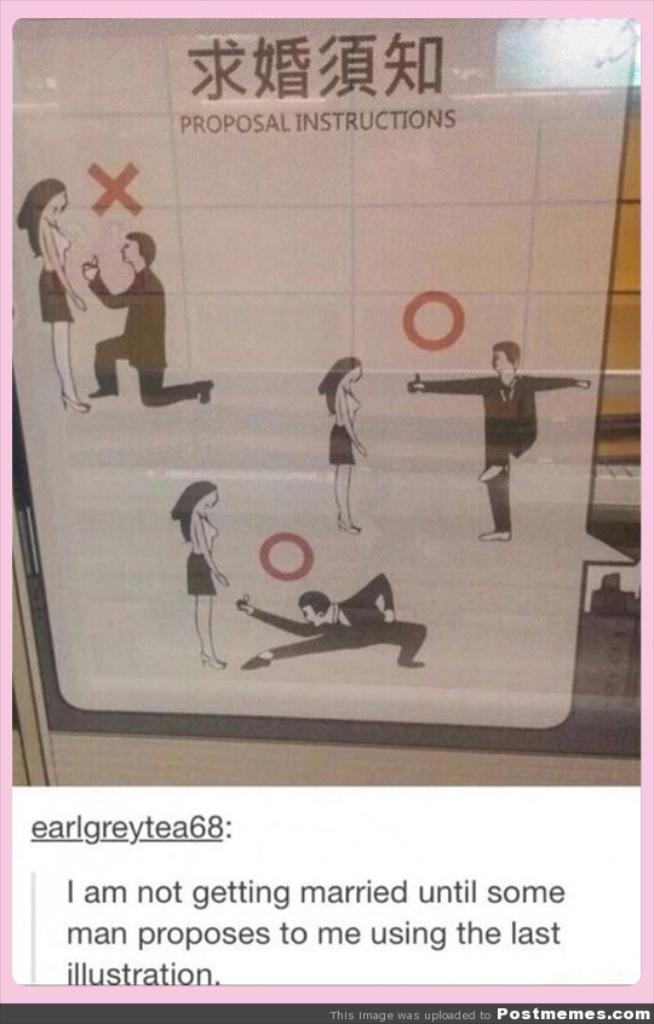What is the user's screen name?
Offer a terse response. Earlgreytea68. What kind of instructions are these?
Your answer should be very brief. Proposal. 